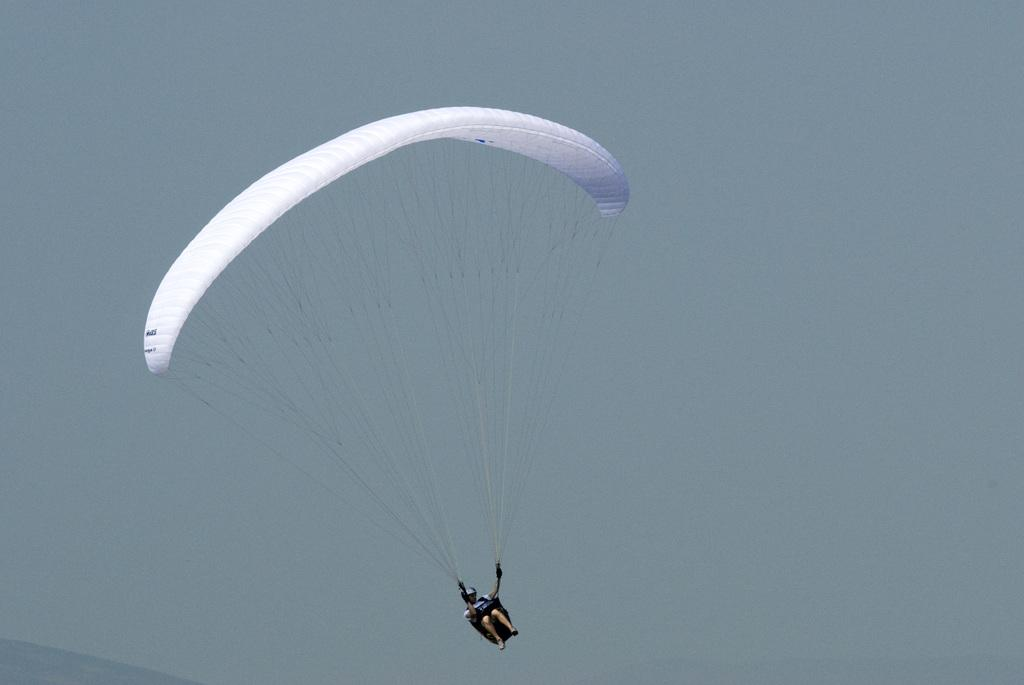Where was the image taken? The image was clicked outside the city. What is happening in the foreground of the image? There is a person flying a parachute in the foreground. What can be seen in the background of the image? The sky is visible in the background of the image. What is the person's opinion about the sense of the eye in the image? There is no information about the person's opinion or the sense of the eye in the image, as the focus is on the person flying a parachute and the sky in the background. 